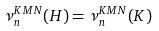<formula> <loc_0><loc_0><loc_500><loc_500>\nu ^ { K M N } _ { n } ( H ) = \nu ^ { K M N } _ { n } ( K )</formula> 